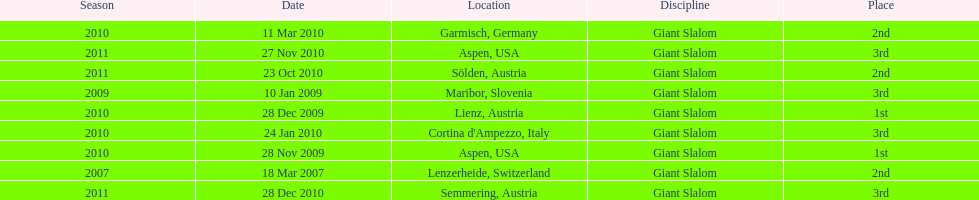Would you be able to parse every entry in this table? {'header': ['Season', 'Date', 'Location', 'Discipline', 'Place'], 'rows': [['2010', '11 Mar 2010', 'Garmisch, Germany', 'Giant Slalom', '2nd'], ['2011', '27 Nov 2010', 'Aspen, USA', 'Giant Slalom', '3rd'], ['2011', '23 Oct 2010', 'Sölden, Austria', 'Giant Slalom', '2nd'], ['2009', '10 Jan 2009', 'Maribor, Slovenia', 'Giant Slalom', '3rd'], ['2010', '28 Dec 2009', 'Lienz, Austria', 'Giant Slalom', '1st'], ['2010', '24 Jan 2010', "Cortina d'Ampezzo, Italy", 'Giant Slalom', '3rd'], ['2010', '28 Nov 2009', 'Aspen, USA', 'Giant Slalom', '1st'], ['2007', '18 Mar 2007', 'Lenzerheide, Switzerland', 'Giant Slalom', '2nd'], ['2011', '28 Dec 2010', 'Semmering, Austria', 'Giant Slalom', '3rd']]} What is the only location in the us? Aspen. 